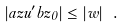Convert formula to latex. <formula><loc_0><loc_0><loc_500><loc_500>| a z u ^ { \prime } b z _ { 0 } | \leq | w | \ .</formula> 